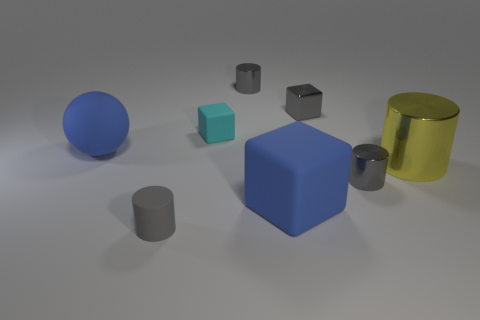What color is the tiny block that is the same material as the large yellow thing?
Keep it short and to the point. Gray. Are there fewer large metallic cylinders than small cyan matte cylinders?
Your answer should be compact. No. There is a object that is right of the sphere and to the left of the cyan matte block; what is it made of?
Ensure brevity in your answer.  Rubber. There is a big blue matte object on the right side of the gray matte cylinder; are there any big metallic objects behind it?
Offer a very short reply. Yes. How many objects are the same color as the matte ball?
Ensure brevity in your answer.  1. What material is the small cube that is the same color as the rubber cylinder?
Offer a terse response. Metal. Does the ball have the same material as the yellow cylinder?
Keep it short and to the point. No. There is a cyan object; are there any gray cylinders on the right side of it?
Make the answer very short. Yes. What material is the blue object that is to the left of the rubber cylinder in front of the blue sphere?
Provide a short and direct response. Rubber. The other rubber thing that is the same shape as the yellow object is what size?
Offer a very short reply. Small. 